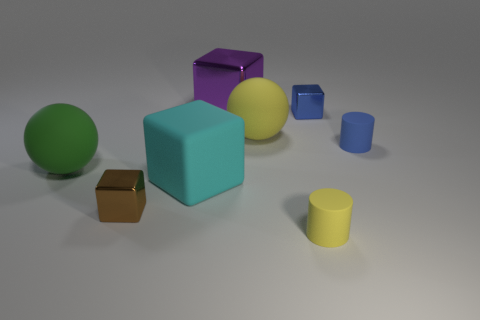Subtract all tiny brown metallic blocks. How many blocks are left? 3 Add 2 small green rubber cubes. How many objects exist? 10 Subtract all purple blocks. How many blocks are left? 3 Subtract all cylinders. How many objects are left? 6 Add 5 large rubber cubes. How many large rubber cubes exist? 6 Subtract 1 cyan blocks. How many objects are left? 7 Subtract 4 blocks. How many blocks are left? 0 Subtract all purple balls. Subtract all brown cylinders. How many balls are left? 2 Subtract all big purple things. Subtract all small gray metal cylinders. How many objects are left? 7 Add 1 yellow spheres. How many yellow spheres are left? 2 